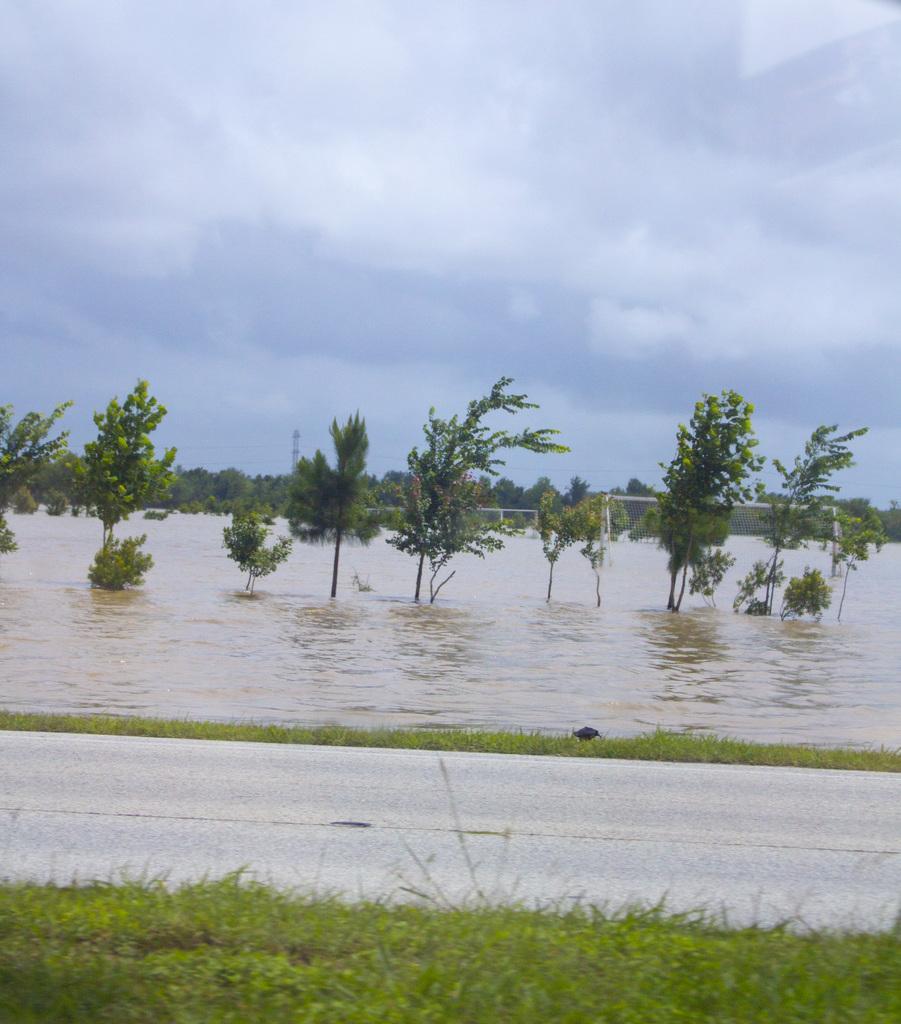How would you summarize this image in a sentence or two? In this image we can see water, trees, tower, sky with clouds and grass. 